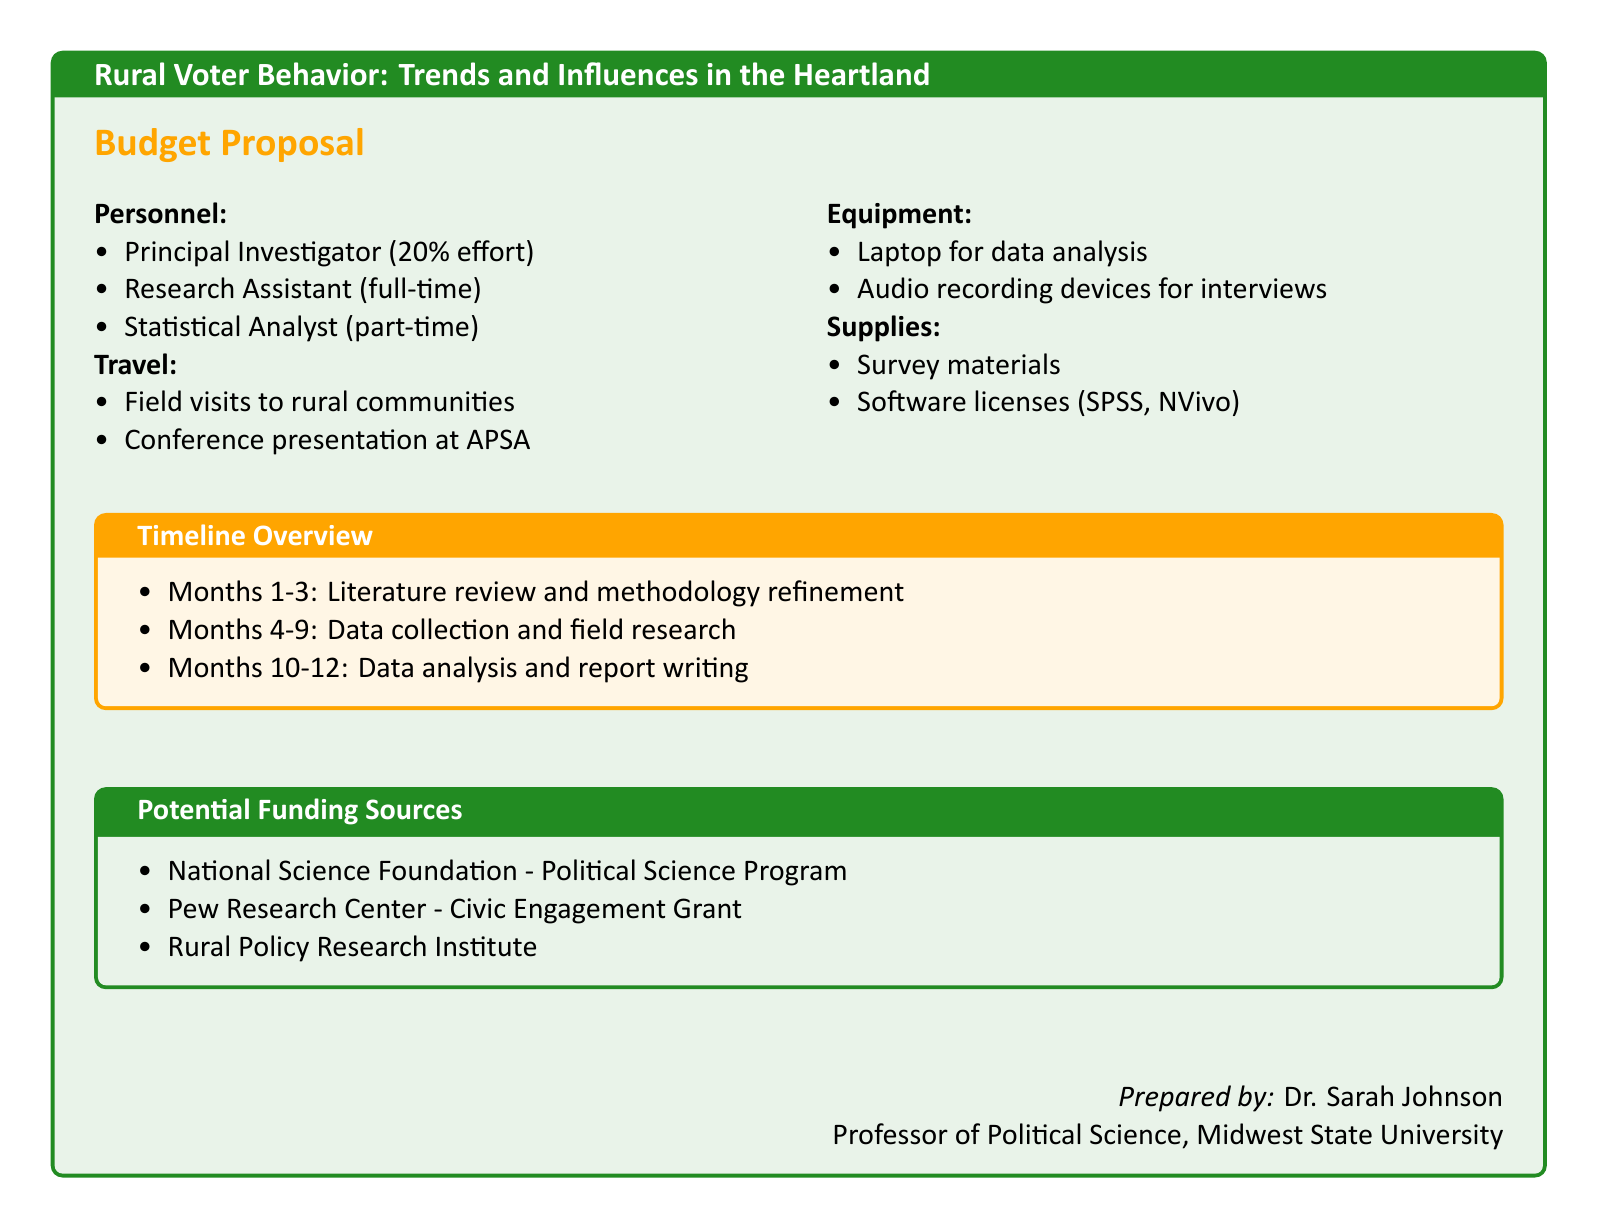What is the title of the proposal? The title is the main focus of the document, indicating the subject of study.
Answer: Rural Voter Behavior: Trends and Influences in the Heartland Who is the Principal Investigator? This information identifies the lead researcher on the project.
Answer: Dr. Sarah Johnson How many months is the total project duration? The total duration is derived from the timeline overview.
Answer: 12 months What percentage of effort does the Principal Investigator allocate? This percentage indicates the time commitment of the Principal Investigator to the project.
Answer: 20% What travel expenses are included in the budget? This asks for specific budget items listed under travel.
Answer: Field visits to rural communities, Conference presentation at APSA What software licenses are included in the supplies? This information reveals the tools required for data analysis and qualitative research.
Answer: SPSS, NVivo Which funding source is dedicated to Political Science? The question seeks to identify a specific funding source that aligns with the project's academic discipline.
Answer: National Science Foundation - Political Science Program What phase occurs in months 10-12? Understanding this phase helps confirm the project timetable for completion.
Answer: Data analysis and report writing 